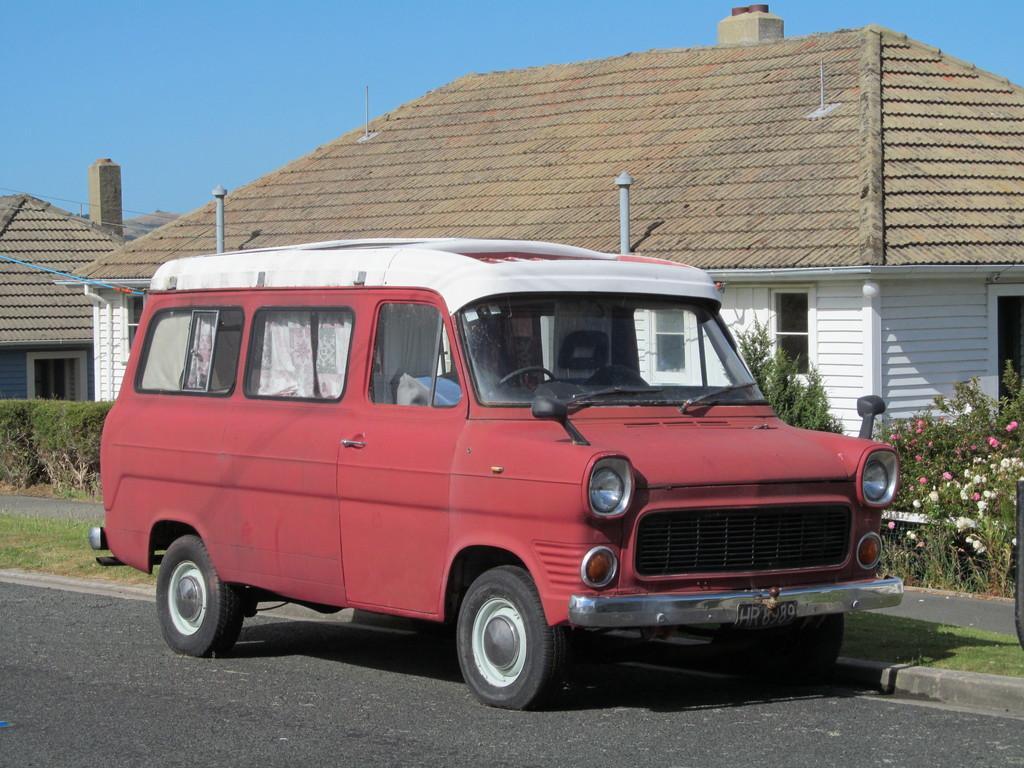Can you describe this image briefly? In this image we can see a vehicle on the road. In the background there are seeds, plants and flowers. At the top there is sky and we can see hedges. 